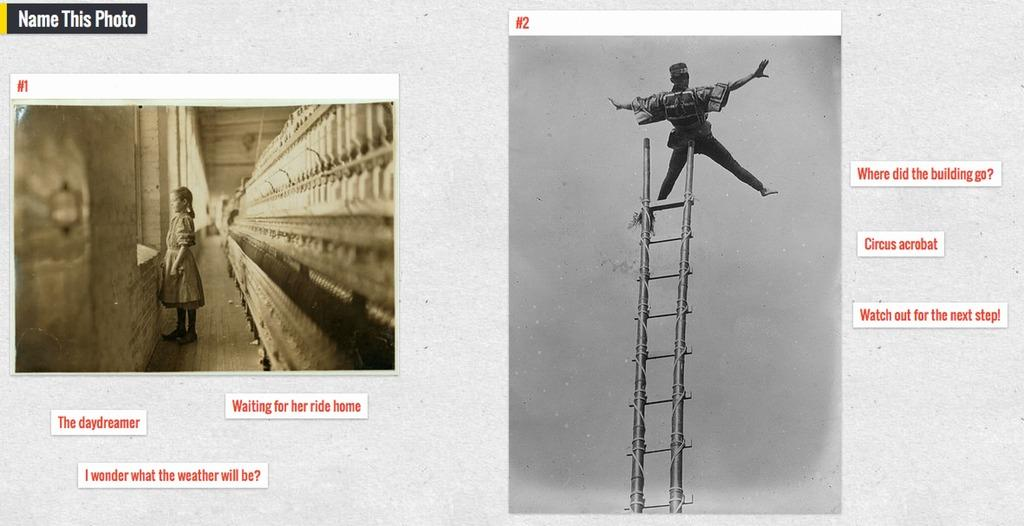<image>
Summarize the visual content of the image. a sign that says where did the building go on it 